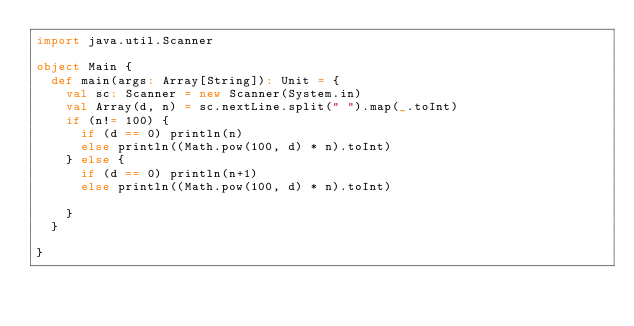Convert code to text. <code><loc_0><loc_0><loc_500><loc_500><_Scala_>import java.util.Scanner

object Main {
  def main(args: Array[String]): Unit = {
    val sc: Scanner = new Scanner(System.in)
    val Array(d, n) = sc.nextLine.split(" ").map(_.toInt)
    if (n!= 100) {
      if (d == 0) println(n)
      else println((Math.pow(100, d) * n).toInt)
    } else {
      if (d == 0) println(n+1)
      else println((Math.pow(100, d) * n).toInt)

    }
  }

}
</code> 